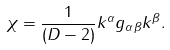Convert formula to latex. <formula><loc_0><loc_0><loc_500><loc_500>\chi = \frac { 1 } { ( D - 2 ) } k ^ { \alpha } g _ { \alpha \beta } k ^ { \beta } .</formula> 